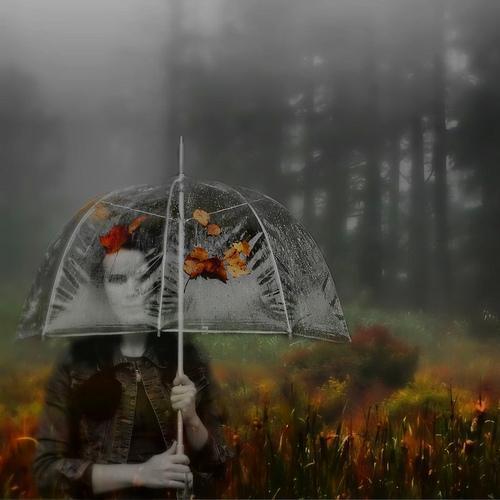Is the caption "The person is outside the umbrella." a true representation of the image?
Answer yes or no. No. 